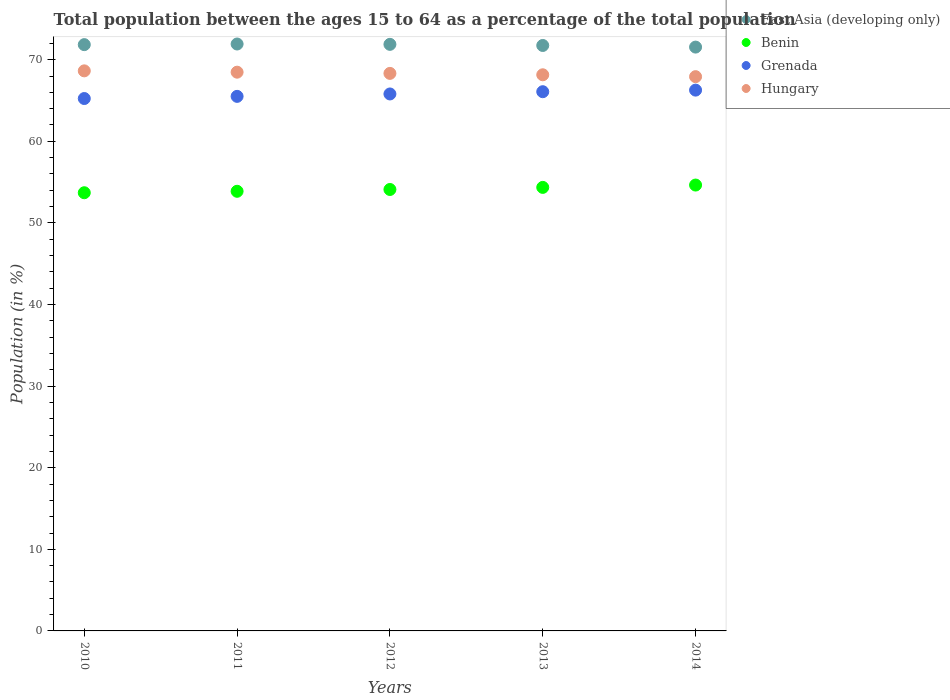How many different coloured dotlines are there?
Ensure brevity in your answer.  4. Is the number of dotlines equal to the number of legend labels?
Ensure brevity in your answer.  Yes. What is the percentage of the population ages 15 to 64 in Hungary in 2011?
Keep it short and to the point. 68.47. Across all years, what is the maximum percentage of the population ages 15 to 64 in Benin?
Provide a short and direct response. 54.64. Across all years, what is the minimum percentage of the population ages 15 to 64 in Benin?
Ensure brevity in your answer.  53.7. In which year was the percentage of the population ages 15 to 64 in Hungary maximum?
Provide a succinct answer. 2010. In which year was the percentage of the population ages 15 to 64 in Benin minimum?
Make the answer very short. 2010. What is the total percentage of the population ages 15 to 64 in Grenada in the graph?
Make the answer very short. 328.91. What is the difference between the percentage of the population ages 15 to 64 in Hungary in 2010 and that in 2014?
Your answer should be very brief. 0.71. What is the difference between the percentage of the population ages 15 to 64 in Benin in 2011 and the percentage of the population ages 15 to 64 in East Asia (developing only) in 2014?
Ensure brevity in your answer.  -17.67. What is the average percentage of the population ages 15 to 64 in Benin per year?
Keep it short and to the point. 54.13. In the year 2013, what is the difference between the percentage of the population ages 15 to 64 in Hungary and percentage of the population ages 15 to 64 in Benin?
Provide a short and direct response. 13.8. In how many years, is the percentage of the population ages 15 to 64 in Grenada greater than 48?
Offer a terse response. 5. What is the ratio of the percentage of the population ages 15 to 64 in Grenada in 2011 to that in 2013?
Keep it short and to the point. 0.99. What is the difference between the highest and the second highest percentage of the population ages 15 to 64 in Hungary?
Keep it short and to the point. 0.16. What is the difference between the highest and the lowest percentage of the population ages 15 to 64 in Grenada?
Provide a short and direct response. 1.03. In how many years, is the percentage of the population ages 15 to 64 in Benin greater than the average percentage of the population ages 15 to 64 in Benin taken over all years?
Provide a short and direct response. 2. Is it the case that in every year, the sum of the percentage of the population ages 15 to 64 in East Asia (developing only) and percentage of the population ages 15 to 64 in Hungary  is greater than the sum of percentage of the population ages 15 to 64 in Grenada and percentage of the population ages 15 to 64 in Benin?
Provide a succinct answer. Yes. Is it the case that in every year, the sum of the percentage of the population ages 15 to 64 in East Asia (developing only) and percentage of the population ages 15 to 64 in Benin  is greater than the percentage of the population ages 15 to 64 in Hungary?
Offer a very short reply. Yes. How many years are there in the graph?
Provide a short and direct response. 5. Does the graph contain any zero values?
Your answer should be compact. No. Does the graph contain grids?
Provide a succinct answer. No. Where does the legend appear in the graph?
Offer a very short reply. Top right. How many legend labels are there?
Keep it short and to the point. 4. How are the legend labels stacked?
Keep it short and to the point. Vertical. What is the title of the graph?
Offer a terse response. Total population between the ages 15 to 64 as a percentage of the total population. Does "Niger" appear as one of the legend labels in the graph?
Ensure brevity in your answer.  No. What is the label or title of the X-axis?
Make the answer very short. Years. What is the label or title of the Y-axis?
Offer a terse response. Population (in %). What is the Population (in %) of East Asia (developing only) in 2010?
Make the answer very short. 71.85. What is the Population (in %) of Benin in 2010?
Your response must be concise. 53.7. What is the Population (in %) in Grenada in 2010?
Your answer should be compact. 65.24. What is the Population (in %) of Hungary in 2010?
Your answer should be very brief. 68.63. What is the Population (in %) in East Asia (developing only) in 2011?
Make the answer very short. 71.92. What is the Population (in %) in Benin in 2011?
Your response must be concise. 53.88. What is the Population (in %) of Grenada in 2011?
Make the answer very short. 65.51. What is the Population (in %) of Hungary in 2011?
Provide a short and direct response. 68.47. What is the Population (in %) of East Asia (developing only) in 2012?
Provide a short and direct response. 71.88. What is the Population (in %) of Benin in 2012?
Ensure brevity in your answer.  54.1. What is the Population (in %) in Grenada in 2012?
Make the answer very short. 65.8. What is the Population (in %) in Hungary in 2012?
Provide a succinct answer. 68.32. What is the Population (in %) of East Asia (developing only) in 2013?
Give a very brief answer. 71.75. What is the Population (in %) in Benin in 2013?
Your response must be concise. 54.35. What is the Population (in %) in Grenada in 2013?
Ensure brevity in your answer.  66.08. What is the Population (in %) in Hungary in 2013?
Provide a short and direct response. 68.15. What is the Population (in %) in East Asia (developing only) in 2014?
Make the answer very short. 71.55. What is the Population (in %) of Benin in 2014?
Offer a very short reply. 54.64. What is the Population (in %) in Grenada in 2014?
Your response must be concise. 66.27. What is the Population (in %) in Hungary in 2014?
Your response must be concise. 67.92. Across all years, what is the maximum Population (in %) in East Asia (developing only)?
Give a very brief answer. 71.92. Across all years, what is the maximum Population (in %) of Benin?
Offer a terse response. 54.64. Across all years, what is the maximum Population (in %) of Grenada?
Your answer should be very brief. 66.27. Across all years, what is the maximum Population (in %) of Hungary?
Your answer should be compact. 68.63. Across all years, what is the minimum Population (in %) in East Asia (developing only)?
Ensure brevity in your answer.  71.55. Across all years, what is the minimum Population (in %) in Benin?
Offer a terse response. 53.7. Across all years, what is the minimum Population (in %) of Grenada?
Your response must be concise. 65.24. Across all years, what is the minimum Population (in %) in Hungary?
Offer a terse response. 67.92. What is the total Population (in %) in East Asia (developing only) in the graph?
Your answer should be compact. 358.95. What is the total Population (in %) in Benin in the graph?
Make the answer very short. 270.67. What is the total Population (in %) in Grenada in the graph?
Ensure brevity in your answer.  328.91. What is the total Population (in %) of Hungary in the graph?
Your response must be concise. 341.51. What is the difference between the Population (in %) of East Asia (developing only) in 2010 and that in 2011?
Your answer should be very brief. -0.08. What is the difference between the Population (in %) in Benin in 2010 and that in 2011?
Offer a very short reply. -0.18. What is the difference between the Population (in %) in Grenada in 2010 and that in 2011?
Your response must be concise. -0.27. What is the difference between the Population (in %) of Hungary in 2010 and that in 2011?
Your answer should be very brief. 0.16. What is the difference between the Population (in %) of East Asia (developing only) in 2010 and that in 2012?
Your answer should be very brief. -0.03. What is the difference between the Population (in %) of Benin in 2010 and that in 2012?
Make the answer very short. -0.4. What is the difference between the Population (in %) of Grenada in 2010 and that in 2012?
Keep it short and to the point. -0.56. What is the difference between the Population (in %) of Hungary in 2010 and that in 2012?
Ensure brevity in your answer.  0.31. What is the difference between the Population (in %) in East Asia (developing only) in 2010 and that in 2013?
Your answer should be very brief. 0.1. What is the difference between the Population (in %) of Benin in 2010 and that in 2013?
Provide a short and direct response. -0.66. What is the difference between the Population (in %) in Grenada in 2010 and that in 2013?
Make the answer very short. -0.84. What is the difference between the Population (in %) in Hungary in 2010 and that in 2013?
Offer a very short reply. 0.48. What is the difference between the Population (in %) of East Asia (developing only) in 2010 and that in 2014?
Ensure brevity in your answer.  0.3. What is the difference between the Population (in %) of Benin in 2010 and that in 2014?
Make the answer very short. -0.94. What is the difference between the Population (in %) of Grenada in 2010 and that in 2014?
Provide a short and direct response. -1.03. What is the difference between the Population (in %) in Hungary in 2010 and that in 2014?
Provide a short and direct response. 0.71. What is the difference between the Population (in %) of East Asia (developing only) in 2011 and that in 2012?
Keep it short and to the point. 0.04. What is the difference between the Population (in %) in Benin in 2011 and that in 2012?
Provide a succinct answer. -0.22. What is the difference between the Population (in %) of Grenada in 2011 and that in 2012?
Offer a very short reply. -0.29. What is the difference between the Population (in %) in Hungary in 2011 and that in 2012?
Your answer should be very brief. 0.15. What is the difference between the Population (in %) in East Asia (developing only) in 2011 and that in 2013?
Provide a succinct answer. 0.18. What is the difference between the Population (in %) of Benin in 2011 and that in 2013?
Your response must be concise. -0.48. What is the difference between the Population (in %) of Grenada in 2011 and that in 2013?
Keep it short and to the point. -0.57. What is the difference between the Population (in %) in Hungary in 2011 and that in 2013?
Offer a very short reply. 0.32. What is the difference between the Population (in %) in East Asia (developing only) in 2011 and that in 2014?
Your answer should be compact. 0.38. What is the difference between the Population (in %) in Benin in 2011 and that in 2014?
Offer a terse response. -0.76. What is the difference between the Population (in %) of Grenada in 2011 and that in 2014?
Offer a terse response. -0.77. What is the difference between the Population (in %) of Hungary in 2011 and that in 2014?
Offer a very short reply. 0.55. What is the difference between the Population (in %) of East Asia (developing only) in 2012 and that in 2013?
Provide a succinct answer. 0.14. What is the difference between the Population (in %) in Benin in 2012 and that in 2013?
Offer a very short reply. -0.26. What is the difference between the Population (in %) in Grenada in 2012 and that in 2013?
Give a very brief answer. -0.28. What is the difference between the Population (in %) in Hungary in 2012 and that in 2013?
Offer a very short reply. 0.17. What is the difference between the Population (in %) of East Asia (developing only) in 2012 and that in 2014?
Provide a short and direct response. 0.34. What is the difference between the Population (in %) in Benin in 2012 and that in 2014?
Your answer should be very brief. -0.54. What is the difference between the Population (in %) of Grenada in 2012 and that in 2014?
Provide a succinct answer. -0.47. What is the difference between the Population (in %) of Hungary in 2012 and that in 2014?
Provide a short and direct response. 0.4. What is the difference between the Population (in %) of East Asia (developing only) in 2013 and that in 2014?
Offer a terse response. 0.2. What is the difference between the Population (in %) of Benin in 2013 and that in 2014?
Give a very brief answer. -0.29. What is the difference between the Population (in %) of Grenada in 2013 and that in 2014?
Ensure brevity in your answer.  -0.19. What is the difference between the Population (in %) of Hungary in 2013 and that in 2014?
Keep it short and to the point. 0.23. What is the difference between the Population (in %) of East Asia (developing only) in 2010 and the Population (in %) of Benin in 2011?
Keep it short and to the point. 17.97. What is the difference between the Population (in %) in East Asia (developing only) in 2010 and the Population (in %) in Grenada in 2011?
Offer a terse response. 6.34. What is the difference between the Population (in %) of East Asia (developing only) in 2010 and the Population (in %) of Hungary in 2011?
Offer a very short reply. 3.38. What is the difference between the Population (in %) in Benin in 2010 and the Population (in %) in Grenada in 2011?
Your response must be concise. -11.81. What is the difference between the Population (in %) of Benin in 2010 and the Population (in %) of Hungary in 2011?
Keep it short and to the point. -14.77. What is the difference between the Population (in %) in Grenada in 2010 and the Population (in %) in Hungary in 2011?
Make the answer very short. -3.23. What is the difference between the Population (in %) in East Asia (developing only) in 2010 and the Population (in %) in Benin in 2012?
Offer a terse response. 17.75. What is the difference between the Population (in %) in East Asia (developing only) in 2010 and the Population (in %) in Grenada in 2012?
Make the answer very short. 6.04. What is the difference between the Population (in %) of East Asia (developing only) in 2010 and the Population (in %) of Hungary in 2012?
Make the answer very short. 3.52. What is the difference between the Population (in %) in Benin in 2010 and the Population (in %) in Grenada in 2012?
Ensure brevity in your answer.  -12.1. What is the difference between the Population (in %) of Benin in 2010 and the Population (in %) of Hungary in 2012?
Give a very brief answer. -14.63. What is the difference between the Population (in %) in Grenada in 2010 and the Population (in %) in Hungary in 2012?
Provide a short and direct response. -3.08. What is the difference between the Population (in %) of East Asia (developing only) in 2010 and the Population (in %) of Benin in 2013?
Your response must be concise. 17.49. What is the difference between the Population (in %) in East Asia (developing only) in 2010 and the Population (in %) in Grenada in 2013?
Keep it short and to the point. 5.77. What is the difference between the Population (in %) in East Asia (developing only) in 2010 and the Population (in %) in Hungary in 2013?
Keep it short and to the point. 3.69. What is the difference between the Population (in %) in Benin in 2010 and the Population (in %) in Grenada in 2013?
Provide a succinct answer. -12.38. What is the difference between the Population (in %) in Benin in 2010 and the Population (in %) in Hungary in 2013?
Your answer should be very brief. -14.46. What is the difference between the Population (in %) of Grenada in 2010 and the Population (in %) of Hungary in 2013?
Make the answer very short. -2.91. What is the difference between the Population (in %) of East Asia (developing only) in 2010 and the Population (in %) of Benin in 2014?
Provide a succinct answer. 17.21. What is the difference between the Population (in %) of East Asia (developing only) in 2010 and the Population (in %) of Grenada in 2014?
Provide a succinct answer. 5.57. What is the difference between the Population (in %) of East Asia (developing only) in 2010 and the Population (in %) of Hungary in 2014?
Keep it short and to the point. 3.92. What is the difference between the Population (in %) of Benin in 2010 and the Population (in %) of Grenada in 2014?
Your answer should be compact. -12.58. What is the difference between the Population (in %) of Benin in 2010 and the Population (in %) of Hungary in 2014?
Offer a very short reply. -14.22. What is the difference between the Population (in %) in Grenada in 2010 and the Population (in %) in Hungary in 2014?
Provide a succinct answer. -2.68. What is the difference between the Population (in %) in East Asia (developing only) in 2011 and the Population (in %) in Benin in 2012?
Provide a succinct answer. 17.83. What is the difference between the Population (in %) in East Asia (developing only) in 2011 and the Population (in %) in Grenada in 2012?
Make the answer very short. 6.12. What is the difference between the Population (in %) in East Asia (developing only) in 2011 and the Population (in %) in Hungary in 2012?
Offer a very short reply. 3.6. What is the difference between the Population (in %) in Benin in 2011 and the Population (in %) in Grenada in 2012?
Your answer should be very brief. -11.93. What is the difference between the Population (in %) in Benin in 2011 and the Population (in %) in Hungary in 2012?
Ensure brevity in your answer.  -14.45. What is the difference between the Population (in %) of Grenada in 2011 and the Population (in %) of Hungary in 2012?
Your answer should be very brief. -2.82. What is the difference between the Population (in %) of East Asia (developing only) in 2011 and the Population (in %) of Benin in 2013?
Offer a very short reply. 17.57. What is the difference between the Population (in %) in East Asia (developing only) in 2011 and the Population (in %) in Grenada in 2013?
Keep it short and to the point. 5.84. What is the difference between the Population (in %) in East Asia (developing only) in 2011 and the Population (in %) in Hungary in 2013?
Your answer should be very brief. 3.77. What is the difference between the Population (in %) in Benin in 2011 and the Population (in %) in Grenada in 2013?
Offer a very short reply. -12.2. What is the difference between the Population (in %) of Benin in 2011 and the Population (in %) of Hungary in 2013?
Give a very brief answer. -14.28. What is the difference between the Population (in %) in Grenada in 2011 and the Population (in %) in Hungary in 2013?
Offer a very short reply. -2.65. What is the difference between the Population (in %) of East Asia (developing only) in 2011 and the Population (in %) of Benin in 2014?
Your answer should be very brief. 17.28. What is the difference between the Population (in %) in East Asia (developing only) in 2011 and the Population (in %) in Grenada in 2014?
Your response must be concise. 5.65. What is the difference between the Population (in %) of East Asia (developing only) in 2011 and the Population (in %) of Hungary in 2014?
Provide a short and direct response. 4. What is the difference between the Population (in %) of Benin in 2011 and the Population (in %) of Grenada in 2014?
Your answer should be very brief. -12.4. What is the difference between the Population (in %) in Benin in 2011 and the Population (in %) in Hungary in 2014?
Ensure brevity in your answer.  -14.05. What is the difference between the Population (in %) of Grenada in 2011 and the Population (in %) of Hungary in 2014?
Make the answer very short. -2.42. What is the difference between the Population (in %) of East Asia (developing only) in 2012 and the Population (in %) of Benin in 2013?
Provide a short and direct response. 17.53. What is the difference between the Population (in %) in East Asia (developing only) in 2012 and the Population (in %) in Grenada in 2013?
Your answer should be compact. 5.8. What is the difference between the Population (in %) in East Asia (developing only) in 2012 and the Population (in %) in Hungary in 2013?
Give a very brief answer. 3.73. What is the difference between the Population (in %) in Benin in 2012 and the Population (in %) in Grenada in 2013?
Ensure brevity in your answer.  -11.98. What is the difference between the Population (in %) of Benin in 2012 and the Population (in %) of Hungary in 2013?
Ensure brevity in your answer.  -14.06. What is the difference between the Population (in %) of Grenada in 2012 and the Population (in %) of Hungary in 2013?
Give a very brief answer. -2.35. What is the difference between the Population (in %) in East Asia (developing only) in 2012 and the Population (in %) in Benin in 2014?
Ensure brevity in your answer.  17.24. What is the difference between the Population (in %) in East Asia (developing only) in 2012 and the Population (in %) in Grenada in 2014?
Your response must be concise. 5.61. What is the difference between the Population (in %) of East Asia (developing only) in 2012 and the Population (in %) of Hungary in 2014?
Provide a short and direct response. 3.96. What is the difference between the Population (in %) of Benin in 2012 and the Population (in %) of Grenada in 2014?
Ensure brevity in your answer.  -12.18. What is the difference between the Population (in %) of Benin in 2012 and the Population (in %) of Hungary in 2014?
Your response must be concise. -13.83. What is the difference between the Population (in %) of Grenada in 2012 and the Population (in %) of Hungary in 2014?
Keep it short and to the point. -2.12. What is the difference between the Population (in %) in East Asia (developing only) in 2013 and the Population (in %) in Benin in 2014?
Provide a succinct answer. 17.1. What is the difference between the Population (in %) in East Asia (developing only) in 2013 and the Population (in %) in Grenada in 2014?
Your answer should be very brief. 5.47. What is the difference between the Population (in %) in East Asia (developing only) in 2013 and the Population (in %) in Hungary in 2014?
Provide a short and direct response. 3.82. What is the difference between the Population (in %) in Benin in 2013 and the Population (in %) in Grenada in 2014?
Keep it short and to the point. -11.92. What is the difference between the Population (in %) of Benin in 2013 and the Population (in %) of Hungary in 2014?
Provide a succinct answer. -13.57. What is the difference between the Population (in %) in Grenada in 2013 and the Population (in %) in Hungary in 2014?
Keep it short and to the point. -1.84. What is the average Population (in %) of East Asia (developing only) per year?
Provide a succinct answer. 71.79. What is the average Population (in %) of Benin per year?
Ensure brevity in your answer.  54.13. What is the average Population (in %) of Grenada per year?
Provide a short and direct response. 65.78. What is the average Population (in %) of Hungary per year?
Keep it short and to the point. 68.3. In the year 2010, what is the difference between the Population (in %) in East Asia (developing only) and Population (in %) in Benin?
Ensure brevity in your answer.  18.15. In the year 2010, what is the difference between the Population (in %) of East Asia (developing only) and Population (in %) of Grenada?
Offer a very short reply. 6.6. In the year 2010, what is the difference between the Population (in %) in East Asia (developing only) and Population (in %) in Hungary?
Your response must be concise. 3.21. In the year 2010, what is the difference between the Population (in %) in Benin and Population (in %) in Grenada?
Give a very brief answer. -11.54. In the year 2010, what is the difference between the Population (in %) of Benin and Population (in %) of Hungary?
Keep it short and to the point. -14.94. In the year 2010, what is the difference between the Population (in %) in Grenada and Population (in %) in Hungary?
Keep it short and to the point. -3.39. In the year 2011, what is the difference between the Population (in %) of East Asia (developing only) and Population (in %) of Benin?
Your answer should be very brief. 18.05. In the year 2011, what is the difference between the Population (in %) in East Asia (developing only) and Population (in %) in Grenada?
Offer a terse response. 6.42. In the year 2011, what is the difference between the Population (in %) in East Asia (developing only) and Population (in %) in Hungary?
Your response must be concise. 3.45. In the year 2011, what is the difference between the Population (in %) of Benin and Population (in %) of Grenada?
Make the answer very short. -11.63. In the year 2011, what is the difference between the Population (in %) of Benin and Population (in %) of Hungary?
Ensure brevity in your answer.  -14.6. In the year 2011, what is the difference between the Population (in %) in Grenada and Population (in %) in Hungary?
Provide a short and direct response. -2.96. In the year 2012, what is the difference between the Population (in %) in East Asia (developing only) and Population (in %) in Benin?
Your answer should be very brief. 17.79. In the year 2012, what is the difference between the Population (in %) of East Asia (developing only) and Population (in %) of Grenada?
Your answer should be compact. 6.08. In the year 2012, what is the difference between the Population (in %) in East Asia (developing only) and Population (in %) in Hungary?
Your response must be concise. 3.56. In the year 2012, what is the difference between the Population (in %) in Benin and Population (in %) in Grenada?
Offer a terse response. -11.71. In the year 2012, what is the difference between the Population (in %) in Benin and Population (in %) in Hungary?
Make the answer very short. -14.23. In the year 2012, what is the difference between the Population (in %) of Grenada and Population (in %) of Hungary?
Ensure brevity in your answer.  -2.52. In the year 2013, what is the difference between the Population (in %) in East Asia (developing only) and Population (in %) in Benin?
Offer a very short reply. 17.39. In the year 2013, what is the difference between the Population (in %) of East Asia (developing only) and Population (in %) of Grenada?
Provide a succinct answer. 5.67. In the year 2013, what is the difference between the Population (in %) of East Asia (developing only) and Population (in %) of Hungary?
Offer a very short reply. 3.59. In the year 2013, what is the difference between the Population (in %) in Benin and Population (in %) in Grenada?
Offer a very short reply. -11.73. In the year 2013, what is the difference between the Population (in %) of Benin and Population (in %) of Hungary?
Your response must be concise. -13.8. In the year 2013, what is the difference between the Population (in %) in Grenada and Population (in %) in Hungary?
Provide a succinct answer. -2.07. In the year 2014, what is the difference between the Population (in %) in East Asia (developing only) and Population (in %) in Benin?
Provide a short and direct response. 16.91. In the year 2014, what is the difference between the Population (in %) of East Asia (developing only) and Population (in %) of Grenada?
Give a very brief answer. 5.27. In the year 2014, what is the difference between the Population (in %) in East Asia (developing only) and Population (in %) in Hungary?
Your response must be concise. 3.62. In the year 2014, what is the difference between the Population (in %) in Benin and Population (in %) in Grenada?
Provide a short and direct response. -11.63. In the year 2014, what is the difference between the Population (in %) in Benin and Population (in %) in Hungary?
Offer a very short reply. -13.28. In the year 2014, what is the difference between the Population (in %) of Grenada and Population (in %) of Hungary?
Offer a terse response. -1.65. What is the ratio of the Population (in %) in Hungary in 2010 to that in 2011?
Ensure brevity in your answer.  1. What is the ratio of the Population (in %) in East Asia (developing only) in 2010 to that in 2012?
Provide a short and direct response. 1. What is the ratio of the Population (in %) in Benin in 2010 to that in 2013?
Your response must be concise. 0.99. What is the ratio of the Population (in %) in Grenada in 2010 to that in 2013?
Your response must be concise. 0.99. What is the ratio of the Population (in %) of Hungary in 2010 to that in 2013?
Keep it short and to the point. 1.01. What is the ratio of the Population (in %) of East Asia (developing only) in 2010 to that in 2014?
Your response must be concise. 1. What is the ratio of the Population (in %) of Benin in 2010 to that in 2014?
Offer a terse response. 0.98. What is the ratio of the Population (in %) in Grenada in 2010 to that in 2014?
Provide a short and direct response. 0.98. What is the ratio of the Population (in %) in Hungary in 2010 to that in 2014?
Offer a very short reply. 1.01. What is the ratio of the Population (in %) of East Asia (developing only) in 2011 to that in 2012?
Give a very brief answer. 1. What is the ratio of the Population (in %) of Benin in 2011 to that in 2012?
Give a very brief answer. 1. What is the ratio of the Population (in %) of Grenada in 2011 to that in 2012?
Offer a very short reply. 1. What is the ratio of the Population (in %) in Hungary in 2011 to that in 2012?
Offer a very short reply. 1. What is the ratio of the Population (in %) in East Asia (developing only) in 2011 to that in 2013?
Make the answer very short. 1. What is the ratio of the Population (in %) in Benin in 2011 to that in 2013?
Your answer should be compact. 0.99. What is the ratio of the Population (in %) of Grenada in 2011 to that in 2013?
Provide a succinct answer. 0.99. What is the ratio of the Population (in %) in Grenada in 2011 to that in 2014?
Provide a short and direct response. 0.99. What is the ratio of the Population (in %) of Benin in 2012 to that in 2013?
Make the answer very short. 1. What is the ratio of the Population (in %) in Hungary in 2012 to that in 2013?
Provide a succinct answer. 1. What is the ratio of the Population (in %) in Benin in 2012 to that in 2014?
Your response must be concise. 0.99. What is the ratio of the Population (in %) in Hungary in 2012 to that in 2014?
Your answer should be compact. 1.01. What is the ratio of the Population (in %) of East Asia (developing only) in 2013 to that in 2014?
Give a very brief answer. 1. What is the ratio of the Population (in %) in Grenada in 2013 to that in 2014?
Your response must be concise. 1. What is the ratio of the Population (in %) in Hungary in 2013 to that in 2014?
Your response must be concise. 1. What is the difference between the highest and the second highest Population (in %) in East Asia (developing only)?
Your answer should be very brief. 0.04. What is the difference between the highest and the second highest Population (in %) in Benin?
Your answer should be very brief. 0.29. What is the difference between the highest and the second highest Population (in %) in Grenada?
Keep it short and to the point. 0.19. What is the difference between the highest and the second highest Population (in %) in Hungary?
Offer a very short reply. 0.16. What is the difference between the highest and the lowest Population (in %) of East Asia (developing only)?
Offer a terse response. 0.38. What is the difference between the highest and the lowest Population (in %) of Benin?
Your answer should be very brief. 0.94. What is the difference between the highest and the lowest Population (in %) in Grenada?
Ensure brevity in your answer.  1.03. What is the difference between the highest and the lowest Population (in %) of Hungary?
Provide a succinct answer. 0.71. 